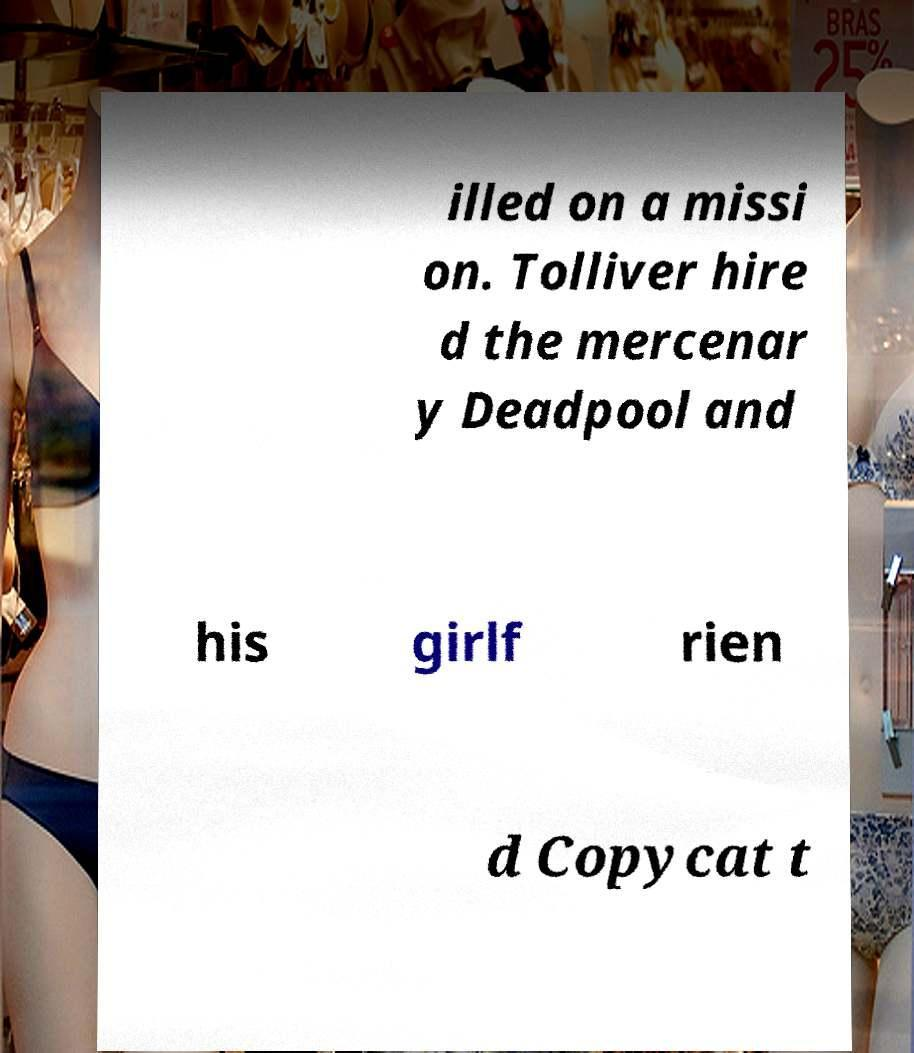Could you assist in decoding the text presented in this image and type it out clearly? illed on a missi on. Tolliver hire d the mercenar y Deadpool and his girlf rien d Copycat t 